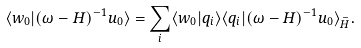Convert formula to latex. <formula><loc_0><loc_0><loc_500><loc_500>\langle w _ { 0 } | ( \omega - H ) ^ { - 1 } u _ { 0 } \rangle = \sum _ { i } \langle w _ { 0 } | q _ { i } \rangle \langle q _ { i } | ( \omega - H ) ^ { - 1 } u _ { 0 } \rangle _ { \bar { H } } .</formula> 